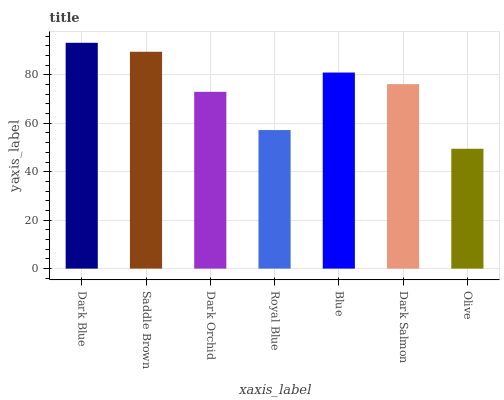Is Olive the minimum?
Answer yes or no. Yes. Is Dark Blue the maximum?
Answer yes or no. Yes. Is Saddle Brown the minimum?
Answer yes or no. No. Is Saddle Brown the maximum?
Answer yes or no. No. Is Dark Blue greater than Saddle Brown?
Answer yes or no. Yes. Is Saddle Brown less than Dark Blue?
Answer yes or no. Yes. Is Saddle Brown greater than Dark Blue?
Answer yes or no. No. Is Dark Blue less than Saddle Brown?
Answer yes or no. No. Is Dark Salmon the high median?
Answer yes or no. Yes. Is Dark Salmon the low median?
Answer yes or no. Yes. Is Blue the high median?
Answer yes or no. No. Is Dark Blue the low median?
Answer yes or no. No. 